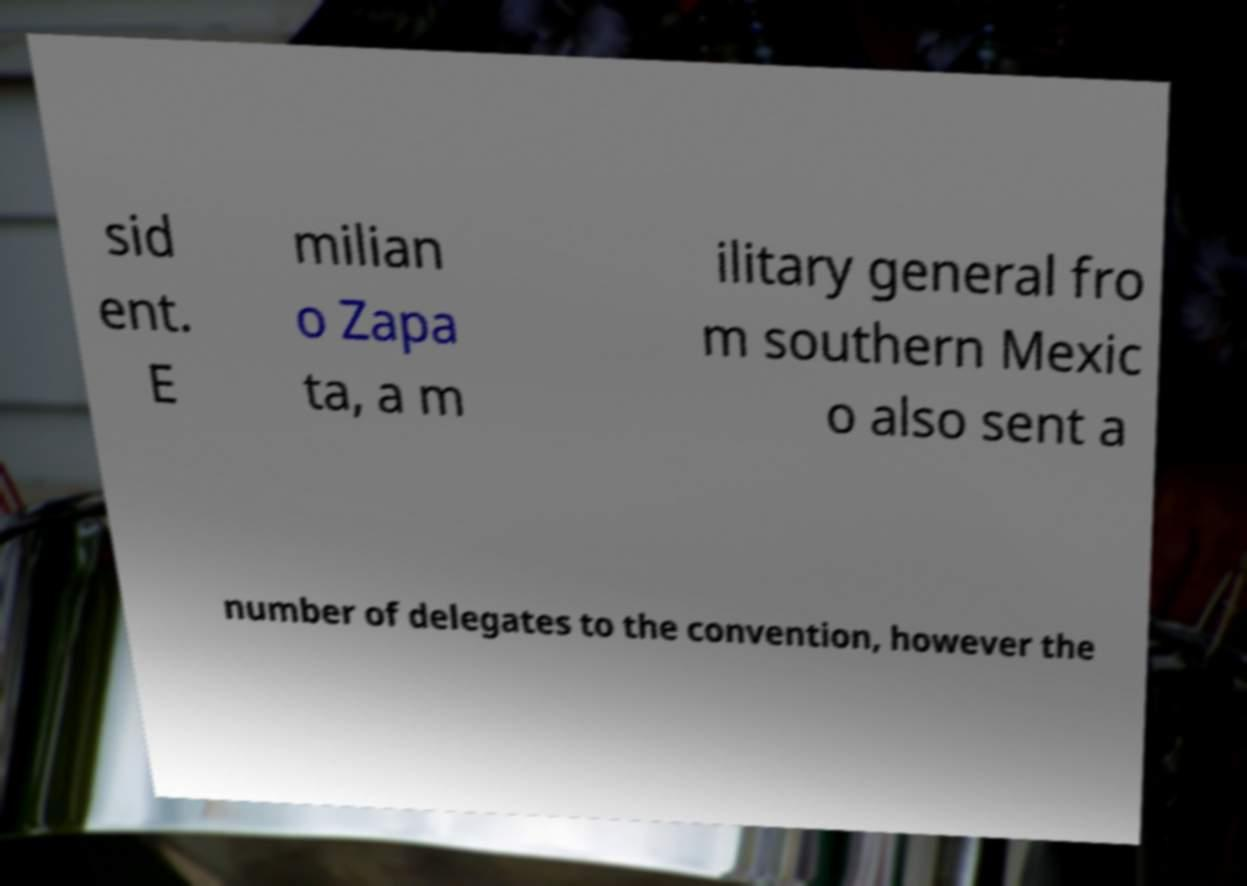Can you read and provide the text displayed in the image?This photo seems to have some interesting text. Can you extract and type it out for me? sid ent. E milian o Zapa ta, a m ilitary general fro m southern Mexic o also sent a number of delegates to the convention, however the 